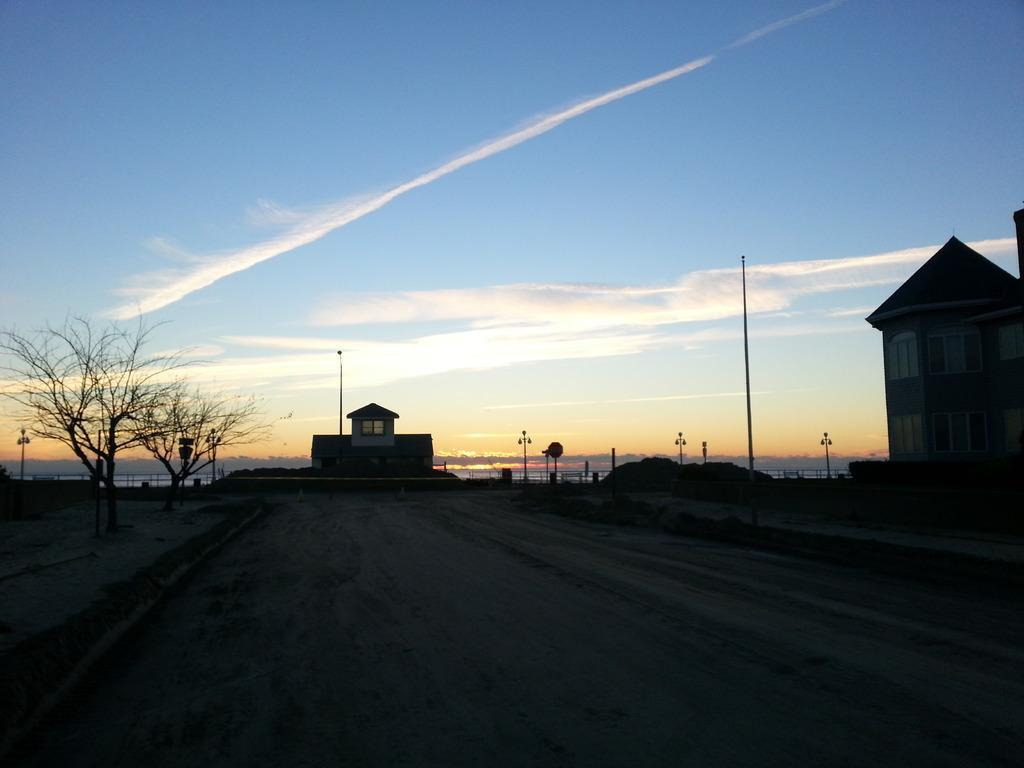What type of structure is visible in the image? There is a building in the image. What other natural elements can be seen in the image? There are trees in the image. What are the poles used for in the image? The purpose of the poles is not specified in the image, but they could be used for various purposes such as lighting or signage. What is the condition of the sky in the image? The sky is clear in the image. Can you tell me how many partners are visible in the image? There is no mention of partners in the image; it features a building, trees, and poles. What type of comparison can be made between the building and the tub in the image? There is no tub present in the image, so no comparison can be made. 